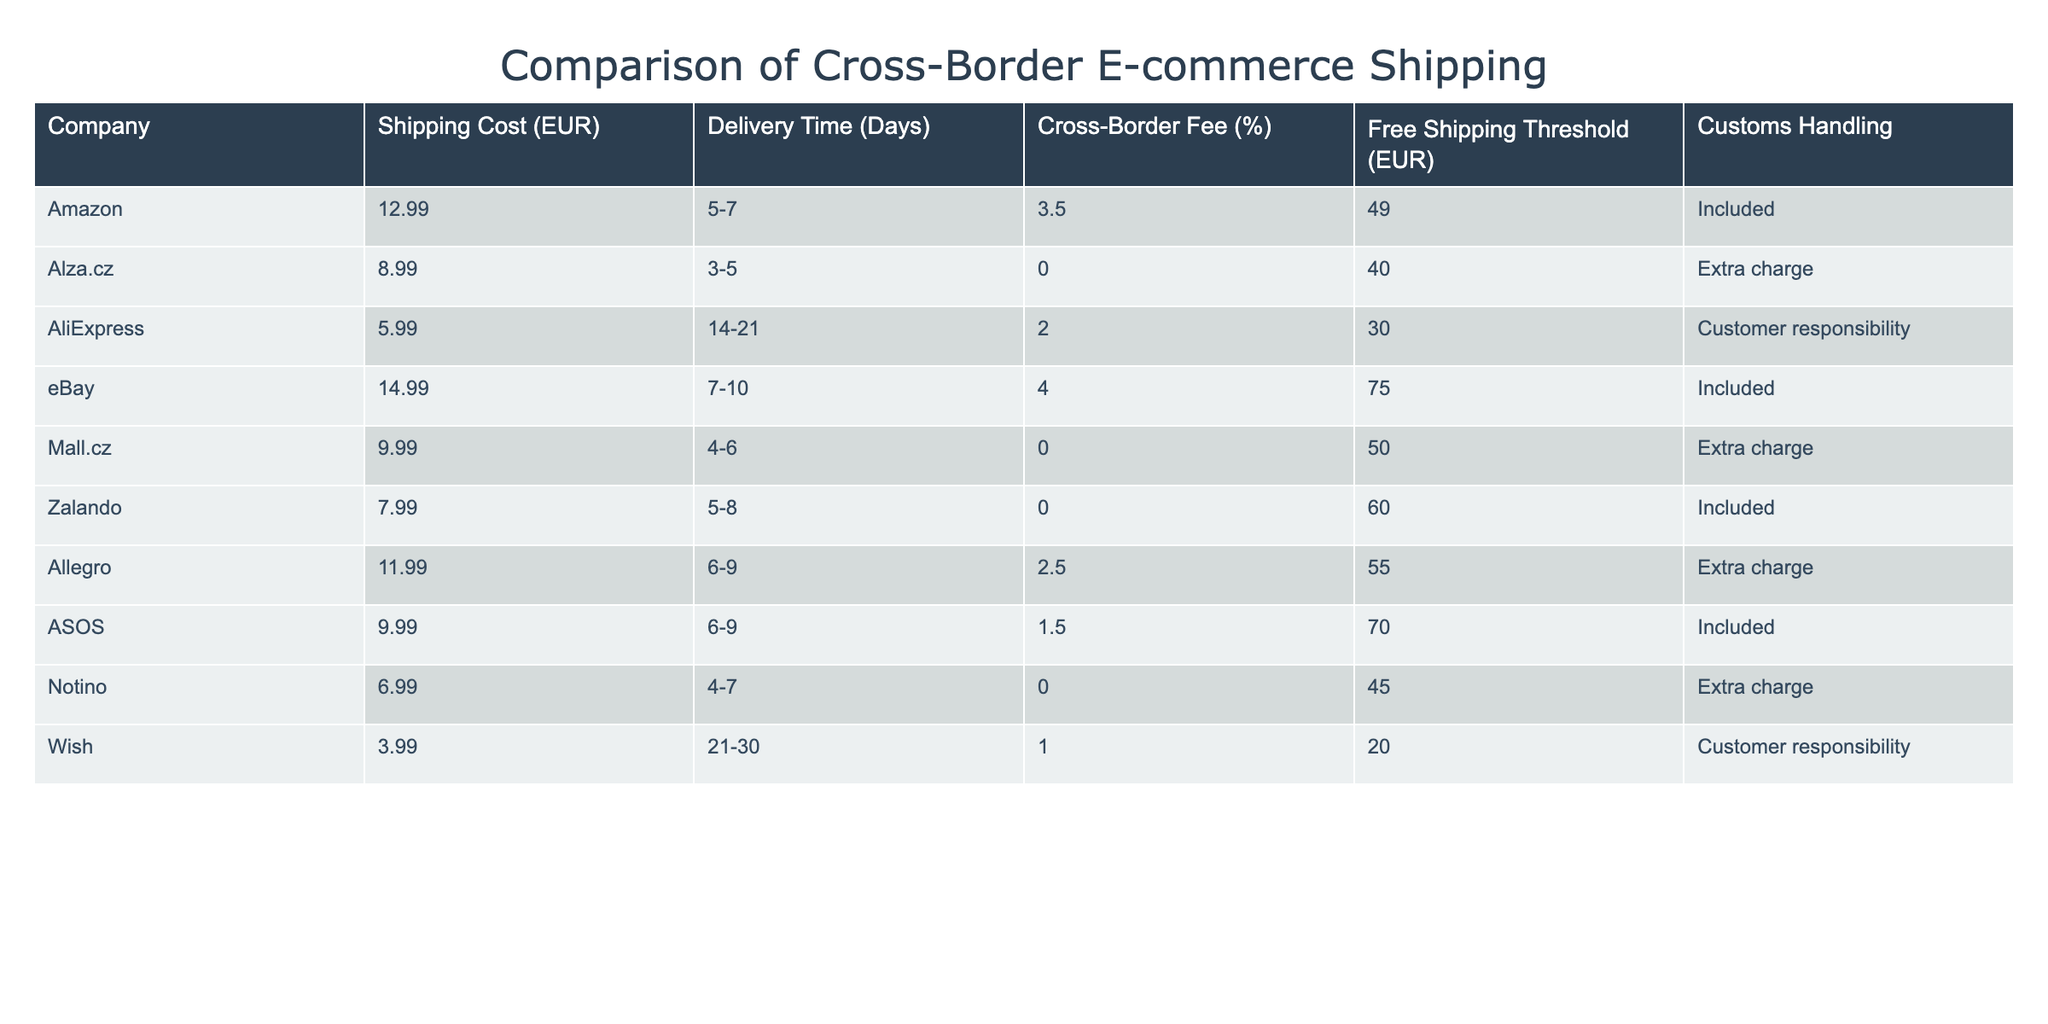What is the shipping cost for AliExpress? The table shows a specific shipping cost of 5.99 EUR for AliExpress.
Answer: 5.99 EUR Which company offers the shortest delivery time? By examining the 'Delivery Time' column, Alza.cz offers a delivery time of 3-5 days, which is the shortest compared to other companies listed.
Answer: Alza.cz What is the average shipping cost among all companies? To find the average, sum all shipping costs (12.99 + 8.99 + 5.99 + 14.99 + 9.99 + 7.99 + 11.99 + 9.99 + 6.99 + 3.99) = 90.90 EUR. Then, divide this total by the number of companies (10): 90.90 / 10 = 9.09 EUR.
Answer: 9.09 EUR Is there a company that does not charge a cross-border fee? By reviewing the 'Cross-Border Fee (%)' column, we see that Alza.cz, Mall.cz, Zalando, and Notino have a cross-border fee of 0%, indicating they do not charge additional fees for cross-border shipping.
Answer: Yes What is the difference in shipping cost between eBay and Wish? First, identify the shipping costs for both eBay (14.99 EUR) and Wish (3.99 EUR). The difference is calculated as 14.99 - 3.99 = 11.00 EUR.
Answer: 11.00 EUR Do any companies offer free shipping with a lower threshold than 40 EUR? By examining the 'Free Shipping Threshold (EUR)' column, we find that Wish offers free shipping at 20 EUR, which is lower than 40 EUR. Thus, there is at least one company that meets this criterion.
Answer: Yes What is the customs handling for eBay? In the table, the 'Customs Handling' for eBay is indicated as 'Included', meaning that the customs handling cost is covered in the shipping expenses.
Answer: Included Which company has the highest customs handling responsibility? Looking at the 'Customs Handling' column, both AliExpress and Wish have 'Customer responsibility', which indicates the highest requirement for the customer to handle their customs. Therefore, these two companies share this characteristic.
Answer: AliExpress and Wish 